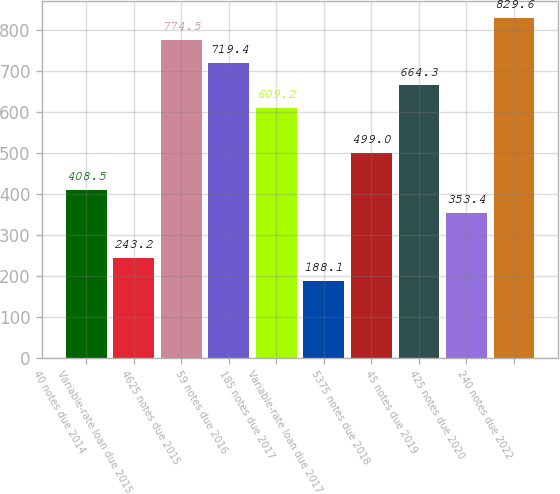<chart> <loc_0><loc_0><loc_500><loc_500><bar_chart><fcel>40 notes due 2014<fcel>Variable-rate loan due 2015<fcel>4625 notes due 2015<fcel>59 notes due 2016<fcel>185 notes due 2017<fcel>Variable-rate loan due 2017<fcel>5375 notes due 2018<fcel>45 notes due 2019<fcel>425 notes due 2020<fcel>240 notes due 2022<nl><fcel>408.5<fcel>243.2<fcel>774.5<fcel>719.4<fcel>609.2<fcel>188.1<fcel>499<fcel>664.3<fcel>353.4<fcel>829.6<nl></chart> 